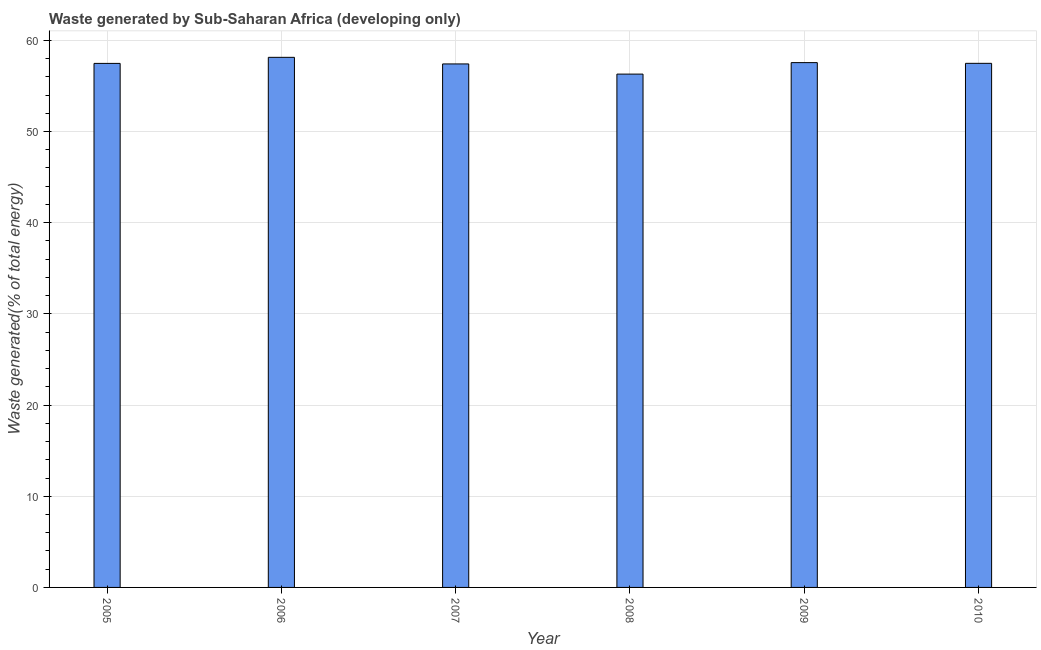What is the title of the graph?
Provide a succinct answer. Waste generated by Sub-Saharan Africa (developing only). What is the label or title of the X-axis?
Offer a terse response. Year. What is the label or title of the Y-axis?
Keep it short and to the point. Waste generated(% of total energy). What is the amount of waste generated in 2010?
Provide a succinct answer. 57.48. Across all years, what is the maximum amount of waste generated?
Provide a short and direct response. 58.14. Across all years, what is the minimum amount of waste generated?
Offer a very short reply. 56.3. In which year was the amount of waste generated maximum?
Offer a terse response. 2006. In which year was the amount of waste generated minimum?
Provide a short and direct response. 2008. What is the sum of the amount of waste generated?
Your response must be concise. 344.35. What is the difference between the amount of waste generated in 2006 and 2007?
Offer a terse response. 0.72. What is the average amount of waste generated per year?
Keep it short and to the point. 57.39. What is the median amount of waste generated?
Make the answer very short. 57.48. In how many years, is the amount of waste generated greater than 42 %?
Keep it short and to the point. 6. Is the amount of waste generated in 2007 less than that in 2008?
Make the answer very short. No. What is the difference between the highest and the second highest amount of waste generated?
Make the answer very short. 0.58. Is the sum of the amount of waste generated in 2008 and 2010 greater than the maximum amount of waste generated across all years?
Offer a terse response. Yes. What is the difference between the highest and the lowest amount of waste generated?
Provide a short and direct response. 1.84. In how many years, is the amount of waste generated greater than the average amount of waste generated taken over all years?
Make the answer very short. 5. How many years are there in the graph?
Your response must be concise. 6. What is the difference between two consecutive major ticks on the Y-axis?
Offer a very short reply. 10. Are the values on the major ticks of Y-axis written in scientific E-notation?
Provide a short and direct response. No. What is the Waste generated(% of total energy) of 2005?
Provide a succinct answer. 57.47. What is the Waste generated(% of total energy) of 2006?
Ensure brevity in your answer.  58.14. What is the Waste generated(% of total energy) in 2007?
Your answer should be compact. 57.41. What is the Waste generated(% of total energy) in 2008?
Make the answer very short. 56.3. What is the Waste generated(% of total energy) in 2009?
Make the answer very short. 57.56. What is the Waste generated(% of total energy) in 2010?
Give a very brief answer. 57.48. What is the difference between the Waste generated(% of total energy) in 2005 and 2006?
Provide a succinct answer. -0.67. What is the difference between the Waste generated(% of total energy) in 2005 and 2007?
Provide a succinct answer. 0.06. What is the difference between the Waste generated(% of total energy) in 2005 and 2008?
Your response must be concise. 1.17. What is the difference between the Waste generated(% of total energy) in 2005 and 2009?
Your answer should be compact. -0.08. What is the difference between the Waste generated(% of total energy) in 2005 and 2010?
Provide a succinct answer. -0.01. What is the difference between the Waste generated(% of total energy) in 2006 and 2007?
Give a very brief answer. 0.72. What is the difference between the Waste generated(% of total energy) in 2006 and 2008?
Offer a terse response. 1.84. What is the difference between the Waste generated(% of total energy) in 2006 and 2009?
Provide a short and direct response. 0.58. What is the difference between the Waste generated(% of total energy) in 2006 and 2010?
Give a very brief answer. 0.66. What is the difference between the Waste generated(% of total energy) in 2007 and 2008?
Offer a terse response. 1.12. What is the difference between the Waste generated(% of total energy) in 2007 and 2009?
Your answer should be very brief. -0.14. What is the difference between the Waste generated(% of total energy) in 2007 and 2010?
Ensure brevity in your answer.  -0.06. What is the difference between the Waste generated(% of total energy) in 2008 and 2009?
Your response must be concise. -1.26. What is the difference between the Waste generated(% of total energy) in 2008 and 2010?
Make the answer very short. -1.18. What is the difference between the Waste generated(% of total energy) in 2009 and 2010?
Your answer should be very brief. 0.08. What is the ratio of the Waste generated(% of total energy) in 2005 to that in 2007?
Ensure brevity in your answer.  1. What is the ratio of the Waste generated(% of total energy) in 2005 to that in 2008?
Offer a terse response. 1.02. What is the ratio of the Waste generated(% of total energy) in 2005 to that in 2010?
Make the answer very short. 1. What is the ratio of the Waste generated(% of total energy) in 2006 to that in 2008?
Provide a short and direct response. 1.03. 